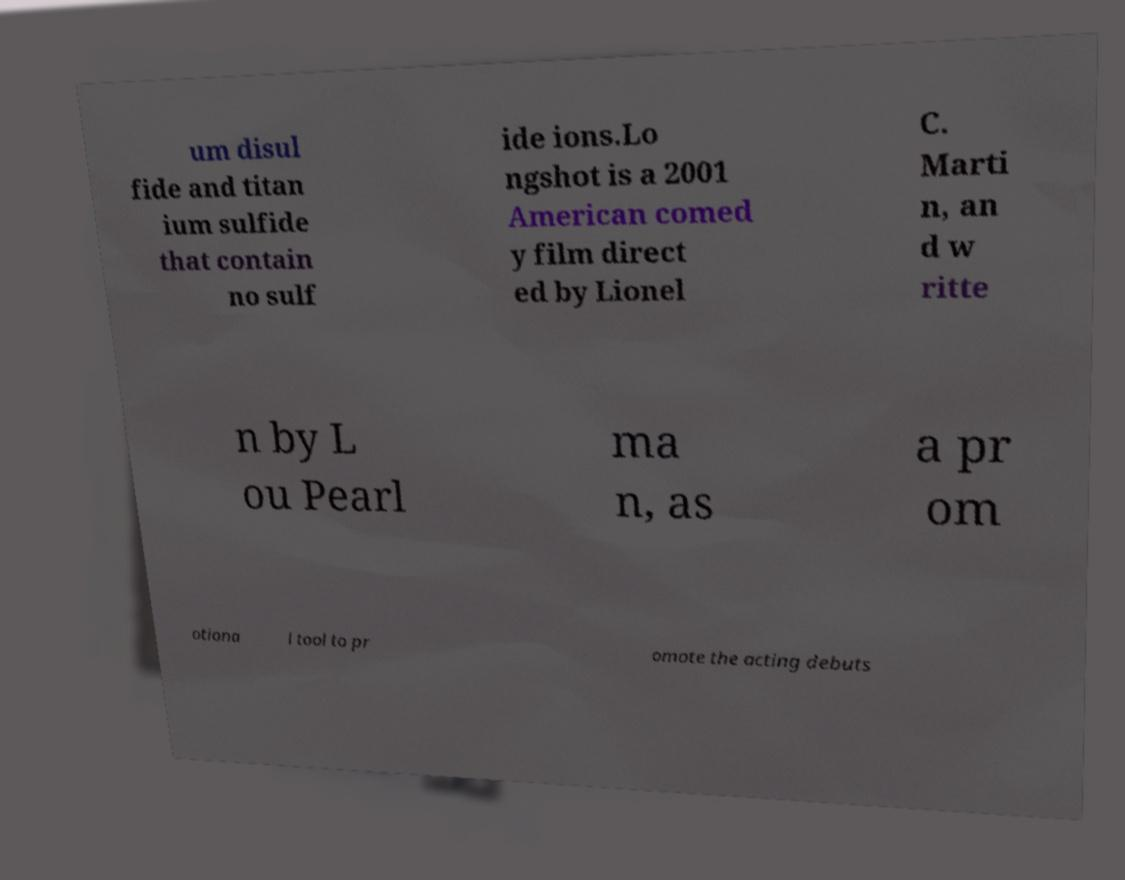There's text embedded in this image that I need extracted. Can you transcribe it verbatim? um disul fide and titan ium sulfide that contain no sulf ide ions.Lo ngshot is a 2001 American comed y film direct ed by Lionel C. Marti n, an d w ritte n by L ou Pearl ma n, as a pr om otiona l tool to pr omote the acting debuts 